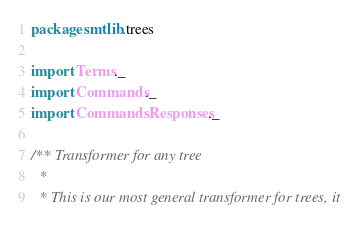<code> <loc_0><loc_0><loc_500><loc_500><_Scala_>package smtlib.trees

import Terms._
import Commands._
import CommandsResponses._

/** Transformer for any tree
  *
  * This is our most general transformer for trees, it</code> 